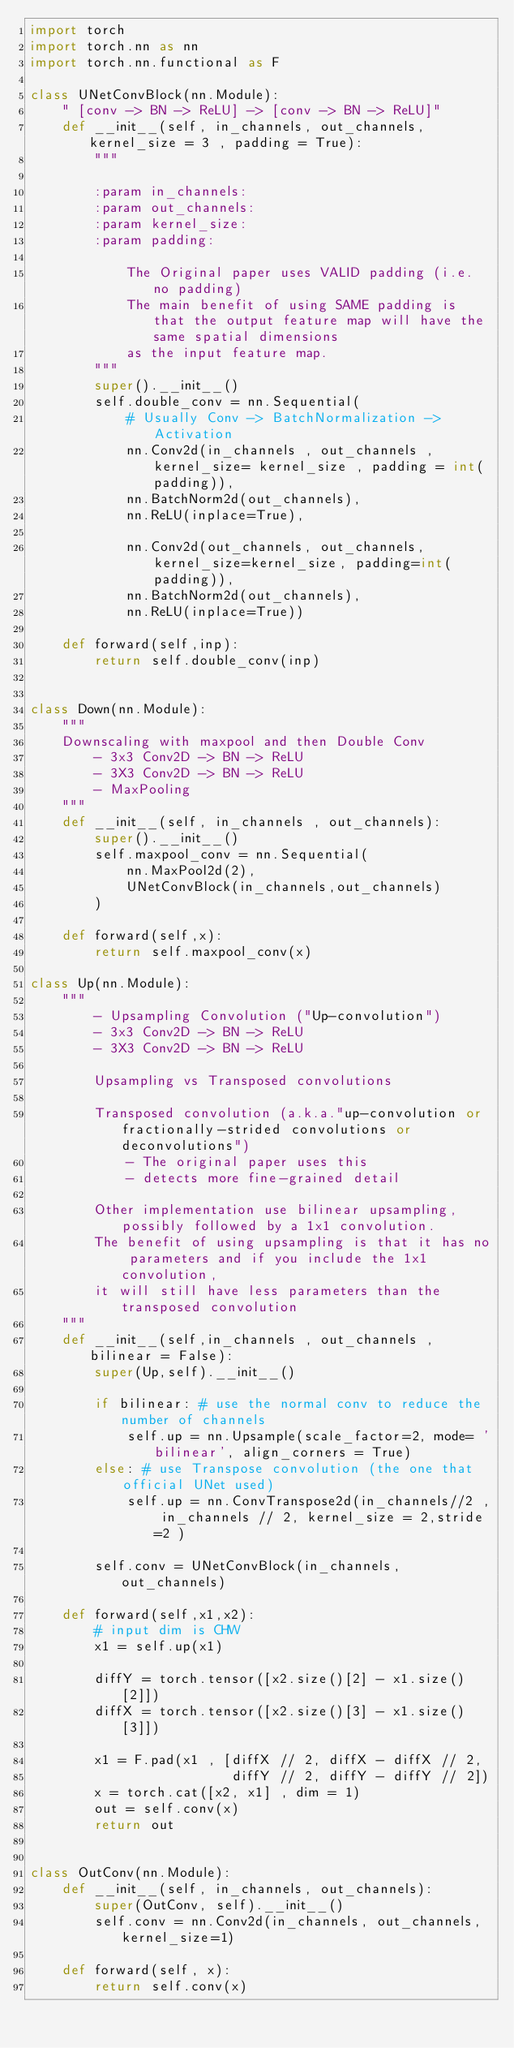Convert code to text. <code><loc_0><loc_0><loc_500><loc_500><_Python_>import torch
import torch.nn as nn
import torch.nn.functional as F

class UNetConvBlock(nn.Module):
    " [conv -> BN -> ReLU] -> [conv -> BN -> ReLU]"
    def __init__(self, in_channels, out_channels, kernel_size = 3 , padding = True):
        """

        :param in_channels:
        :param out_channels:
        :param kernel_size:
        :param padding:

            The Original paper uses VALID padding (i.e. no padding)
            The main benefit of using SAME padding is that the output feature map will have the same spatial dimensions
            as the input feature map.
        """
        super().__init__()
        self.double_conv = nn.Sequential(
            # Usually Conv -> BatchNormalization -> Activation
            nn.Conv2d(in_channels , out_channels , kernel_size= kernel_size , padding = int(padding)),
            nn.BatchNorm2d(out_channels),
            nn.ReLU(inplace=True),

            nn.Conv2d(out_channels, out_channels, kernel_size=kernel_size, padding=int(padding)),
            nn.BatchNorm2d(out_channels),
            nn.ReLU(inplace=True))

    def forward(self,inp):
        return self.double_conv(inp)


class Down(nn.Module):
    """
    Downscaling with maxpool and then Double Conv
        - 3x3 Conv2D -> BN -> ReLU
        - 3X3 Conv2D -> BN -> ReLU
        - MaxPooling
    """
    def __init__(self, in_channels , out_channels):
        super().__init__()
        self.maxpool_conv = nn.Sequential(
            nn.MaxPool2d(2),
            UNetConvBlock(in_channels,out_channels)
        )

    def forward(self,x):
        return self.maxpool_conv(x)

class Up(nn.Module):
    """
        - Upsampling Convolution ("Up-convolution")
        - 3x3 Conv2D -> BN -> ReLU
        - 3X3 Conv2D -> BN -> ReLU

        Upsampling vs Transposed convolutions

        Transposed convolution (a.k.a."up-convolution or fractionally-strided convolutions or deconvolutions")
            - The original paper uses this
            - detects more fine-grained detail

        Other implementation use bilinear upsampling, possibly followed by a 1x1 convolution.
        The benefit of using upsampling is that it has no parameters and if you include the 1x1 convolution,
        it will still have less parameters than the transposed convolution
    """
    def __init__(self,in_channels , out_channels , bilinear = False):
        super(Up,self).__init__()

        if bilinear: # use the normal conv to reduce the number of channels
            self.up = nn.Upsample(scale_factor=2, mode= 'bilinear', align_corners = True)
        else: # use Transpose convolution (the one that official UNet used)
            self.up = nn.ConvTranspose2d(in_channels//2 , in_channels // 2, kernel_size = 2,stride=2 )

        self.conv = UNetConvBlock(in_channels,out_channels)

    def forward(self,x1,x2):
        # input dim is CHW
        x1 = self.up(x1)

        diffY = torch.tensor([x2.size()[2] - x1.size()[2]])
        diffX = torch.tensor([x2.size()[3] - x1.size()[3]])

        x1 = F.pad(x1 , [diffX // 2, diffX - diffX // 2,
                         diffY // 2, diffY - diffY // 2])
        x = torch.cat([x2, x1] , dim = 1)
        out = self.conv(x)
        return out


class OutConv(nn.Module):
    def __init__(self, in_channels, out_channels):
        super(OutConv, self).__init__()
        self.conv = nn.Conv2d(in_channels, out_channels, kernel_size=1)

    def forward(self, x):
        return self.conv(x)</code> 